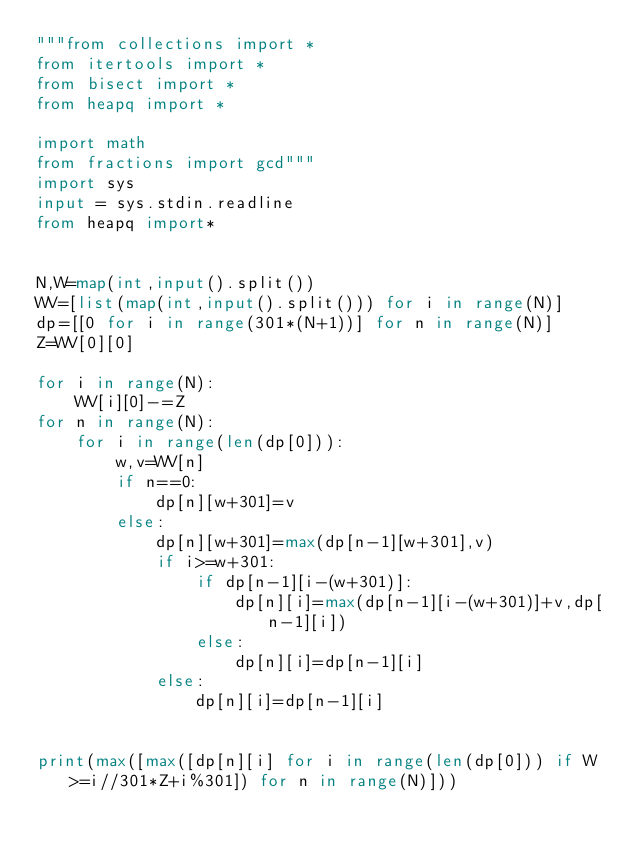<code> <loc_0><loc_0><loc_500><loc_500><_Python_>"""from collections import *
from itertools import *
from bisect import *
from heapq import *

import math
from fractions import gcd"""
import sys
input = sys.stdin.readline
from heapq import*


N,W=map(int,input().split())
WV=[list(map(int,input().split())) for i in range(N)]
dp=[[0 for i in range(301*(N+1))] for n in range(N)]
Z=WV[0][0]

for i in range(N):
    WV[i][0]-=Z
for n in range(N):
    for i in range(len(dp[0])):
        w,v=WV[n]
        if n==0:
            dp[n][w+301]=v
        else:
            dp[n][w+301]=max(dp[n-1][w+301],v)
            if i>=w+301:
                if dp[n-1][i-(w+301)]:
                    dp[n][i]=max(dp[n-1][i-(w+301)]+v,dp[n-1][i])
                else:
                    dp[n][i]=dp[n-1][i]
            else:
                dp[n][i]=dp[n-1][i]


print(max([max([dp[n][i] for i in range(len(dp[0])) if W>=i//301*Z+i%301]) for n in range(N)]))
</code> 